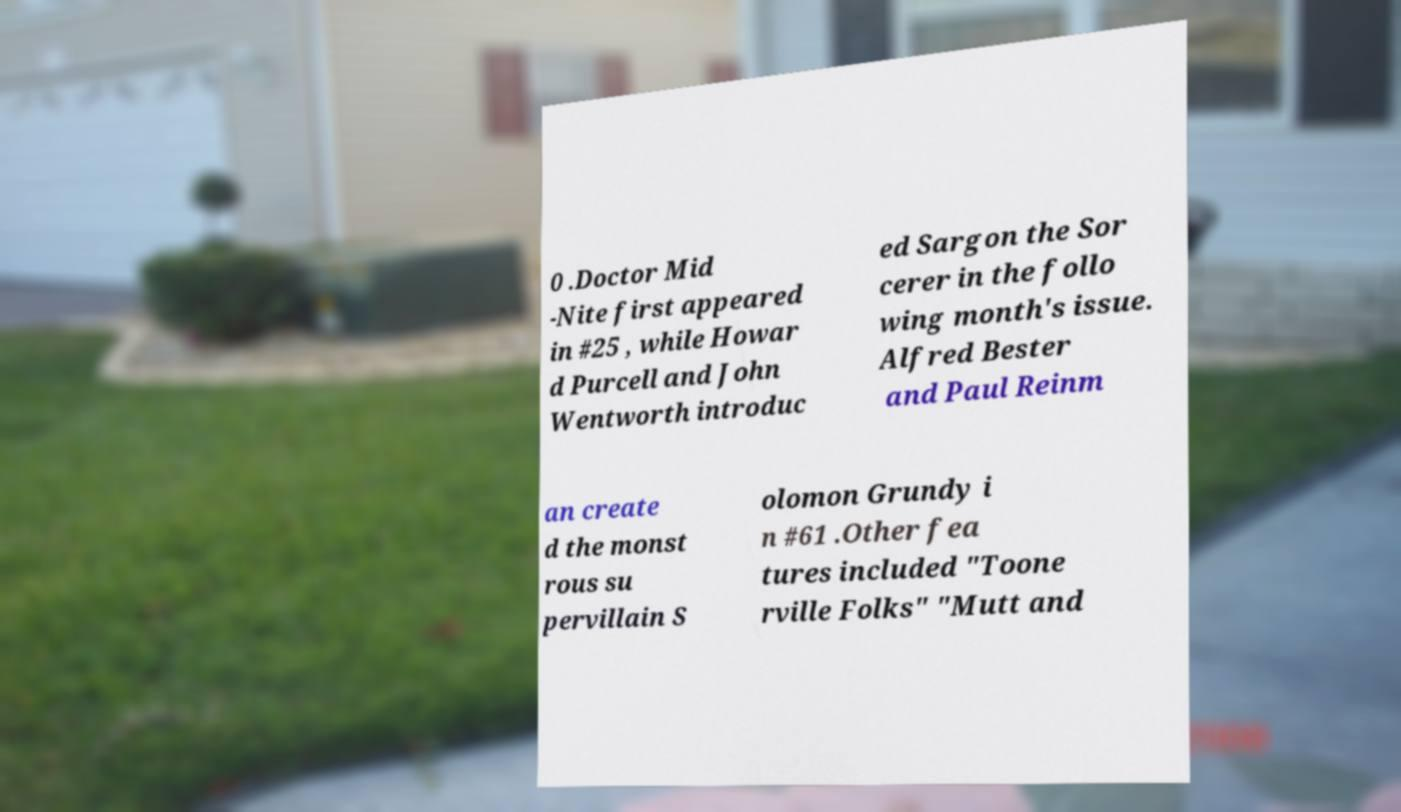For documentation purposes, I need the text within this image transcribed. Could you provide that? 0 .Doctor Mid -Nite first appeared in #25 , while Howar d Purcell and John Wentworth introduc ed Sargon the Sor cerer in the follo wing month's issue. Alfred Bester and Paul Reinm an create d the monst rous su pervillain S olomon Grundy i n #61 .Other fea tures included "Toone rville Folks" "Mutt and 